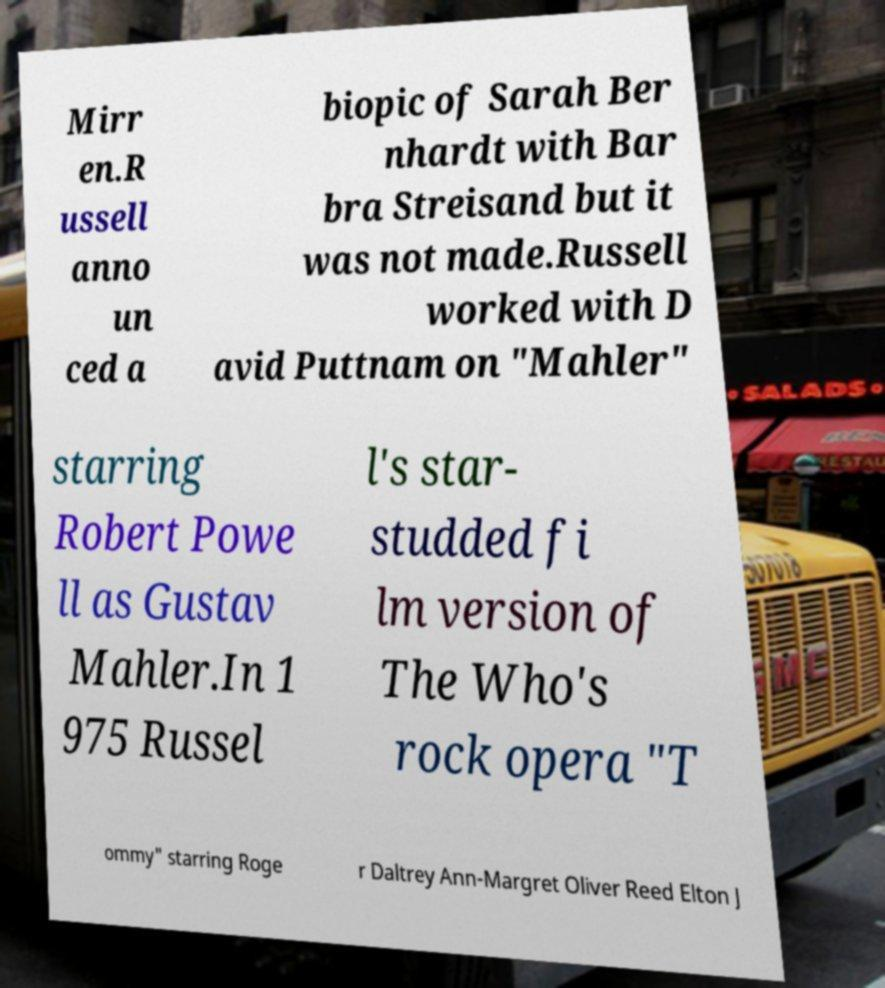Could you extract and type out the text from this image? Mirr en.R ussell anno un ced a biopic of Sarah Ber nhardt with Bar bra Streisand but it was not made.Russell worked with D avid Puttnam on "Mahler" starring Robert Powe ll as Gustav Mahler.In 1 975 Russel l's star- studded fi lm version of The Who's rock opera "T ommy" starring Roge r Daltrey Ann-Margret Oliver Reed Elton J 